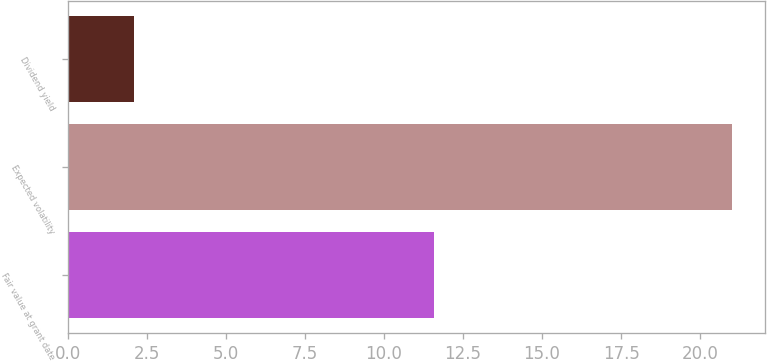Convert chart. <chart><loc_0><loc_0><loc_500><loc_500><bar_chart><fcel>Fair value at grant date<fcel>Expected volatility<fcel>Dividend yield<nl><fcel>11.57<fcel>21<fcel>2.1<nl></chart> 